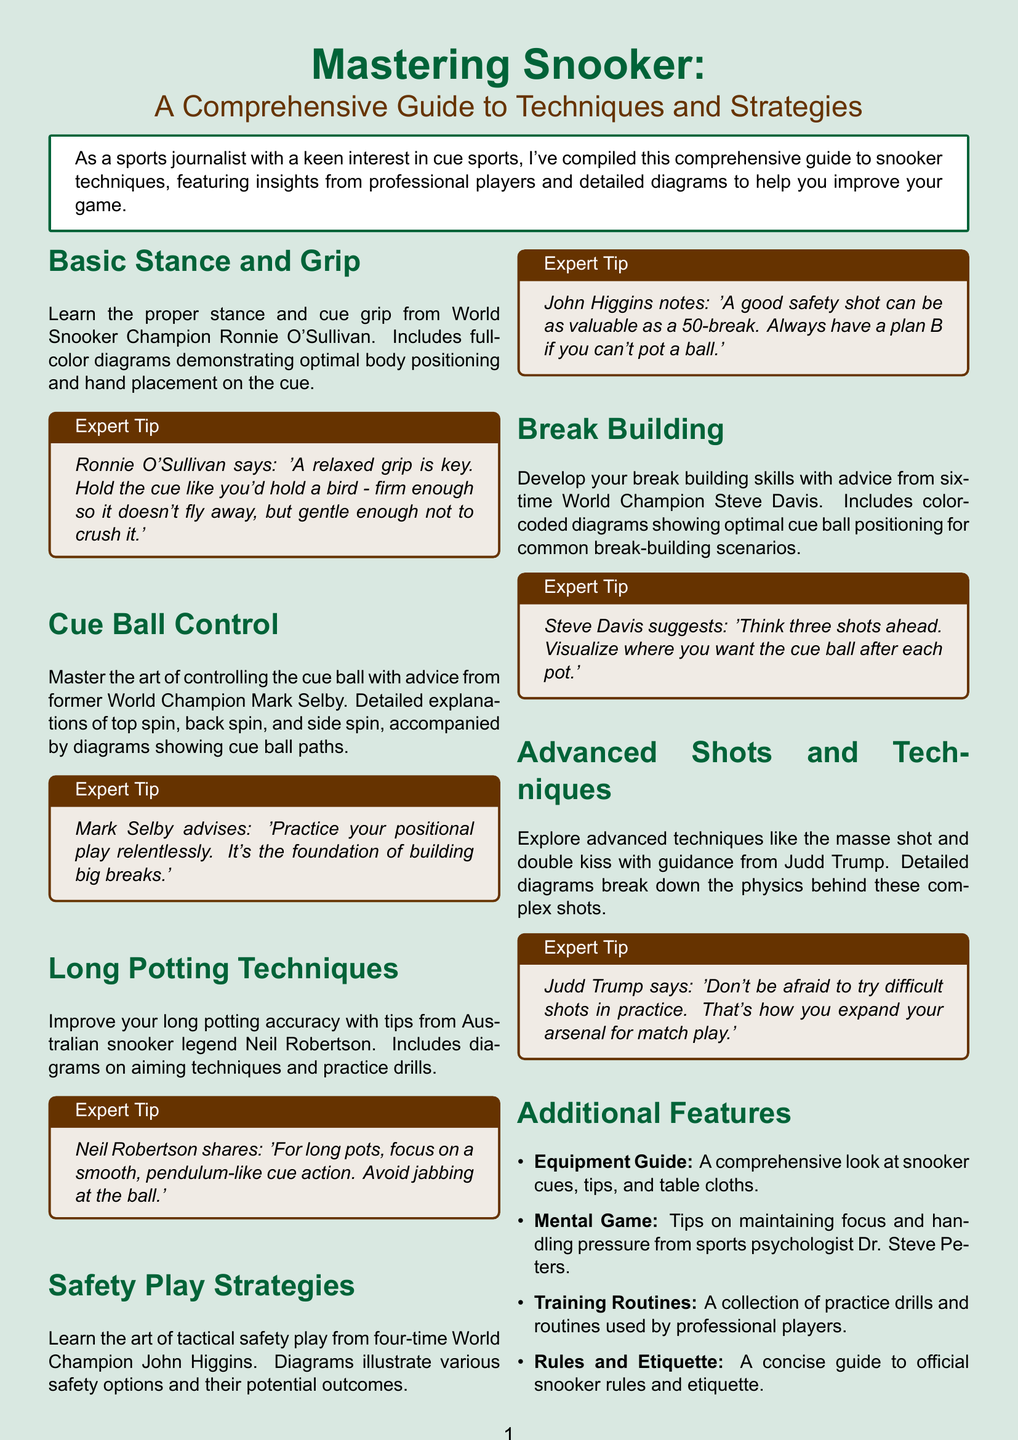what is the title of the guide? The title is the main heading of the brochure and provides an overview of its content.
Answer: Mastering Snooker: A Comprehensive Guide to Techniques and Strategies who provides the expert tip on cue ball control? This requires identifying the professional player associated with that section of the document.
Answer: Mark Selby how many sections are there in the guide? The number of sections can be determined by counting them in the content provided.
Answer: Six what is emphasized as key by Ronnie O'Sullivan? This refers to the important concept mentioned in the expert tip in the Basic Stance and Grip section.
Answer: Relaxed grip which player suggests thinking three shots ahead? This question targets the specific advice given by a professional in the Break Building section.
Answer: Steve Davis what additional feature discusses official snooker rules? This question looks for the specific name of the additional feature related to rules in snooker.
Answer: Rules and Etiquette which advanced technique is mentioned alongside the masse shot? This question relates to the advanced shots discussed in the specific section of the guide.
Answer: Double kiss who is the sports psychologist mentioned in the guide? This requires recalling the name associated with the Mental Game additional feature.
Answer: Dr. Steve Peters 